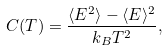<formula> <loc_0><loc_0><loc_500><loc_500>C ( T ) = \frac { \langle E ^ { 2 } \rangle - \langle E \rangle ^ { 2 } } { k _ { B } T ^ { 2 } } ,</formula> 